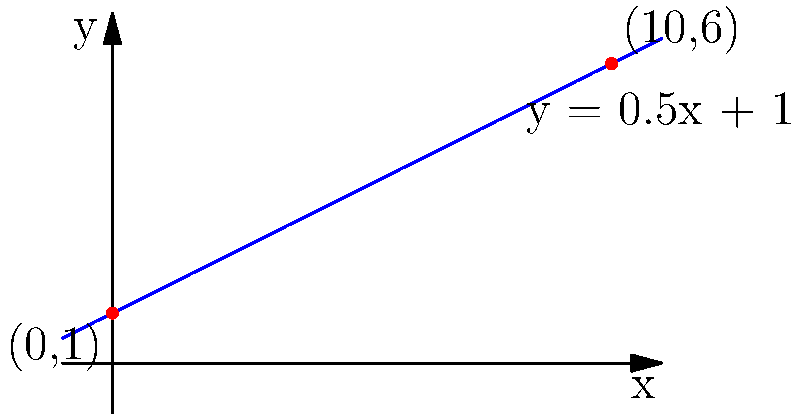As a prop maker, you need to design an angled backdrop for a stage. The stage manager wants the backdrop to start at a height of 1 meter on the left side and reach a height of 6 meters at a distance of 10 meters to the right. Using the slope-intercept form of a line equation $(y = mx + b)$, determine the equation that represents this backdrop placement. What is the slope of the backdrop? To solve this problem, we'll use the slope-intercept form of a line equation: $y = mx + b$, where $m$ is the slope and $b$ is the y-intercept.

Step 1: Identify the two points:
- Left point: $(0, 1)$
- Right point: $(10, 6)$

Step 2: Calculate the slope $(m)$ using the slope formula:
$m = \frac{y_2 - y_1}{x_2 - x_1} = \frac{6 - 1}{10 - 0} = \frac{5}{10} = 0.5$

Step 3: Determine the y-intercept $(b)$:
We know the line passes through $(0, 1)$, so $b = 1$.

Step 4: Write the equation of the line:
$y = 0.5x + 1$

This equation represents the placement of the angled backdrop. The slope of 0.5 means that for every 1 meter horizontally, the backdrop rises 0.5 meters vertically.
Answer: 0.5 